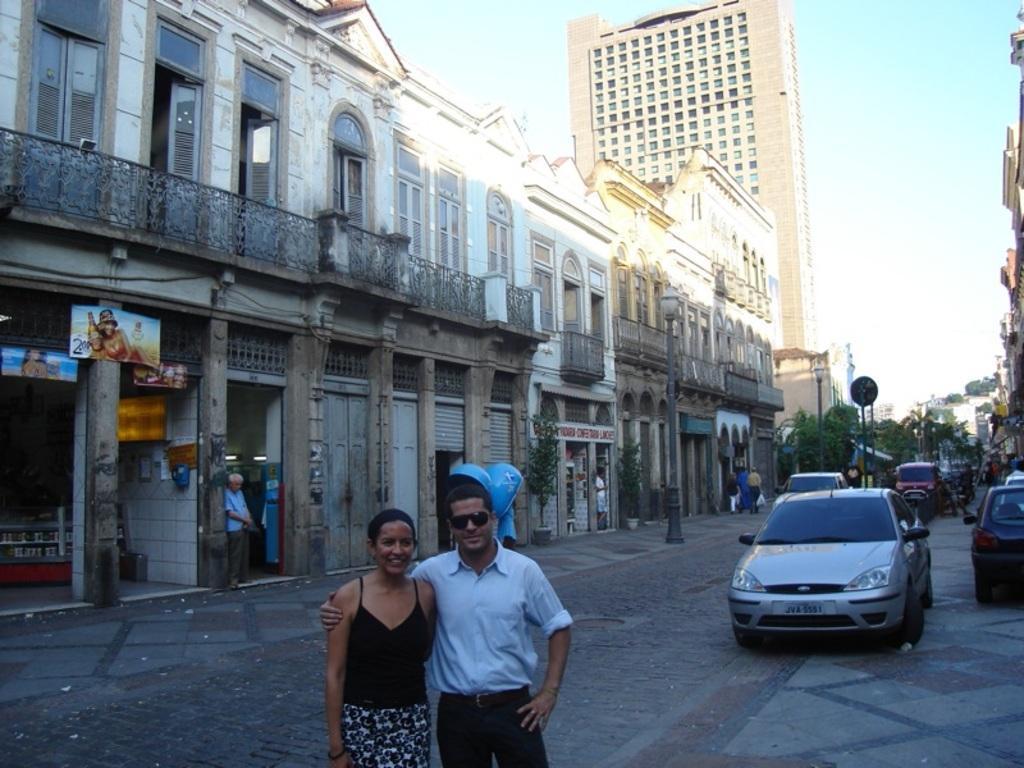Could you give a brief overview of what you see in this image? On the right side of the image we can see some vehicles, trees, board. At the bottom of the image we can see two persons are standing. In the background of the image we can see buildings, boards, shutters, doors, plants, windows. At the top of the image we can see the sky. At the bottom of the image we can see the road. 